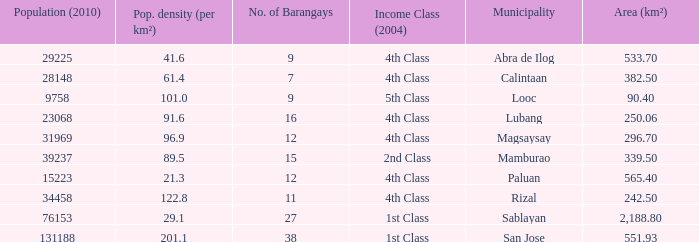What was the smallist population in 2010? 9758.0. 